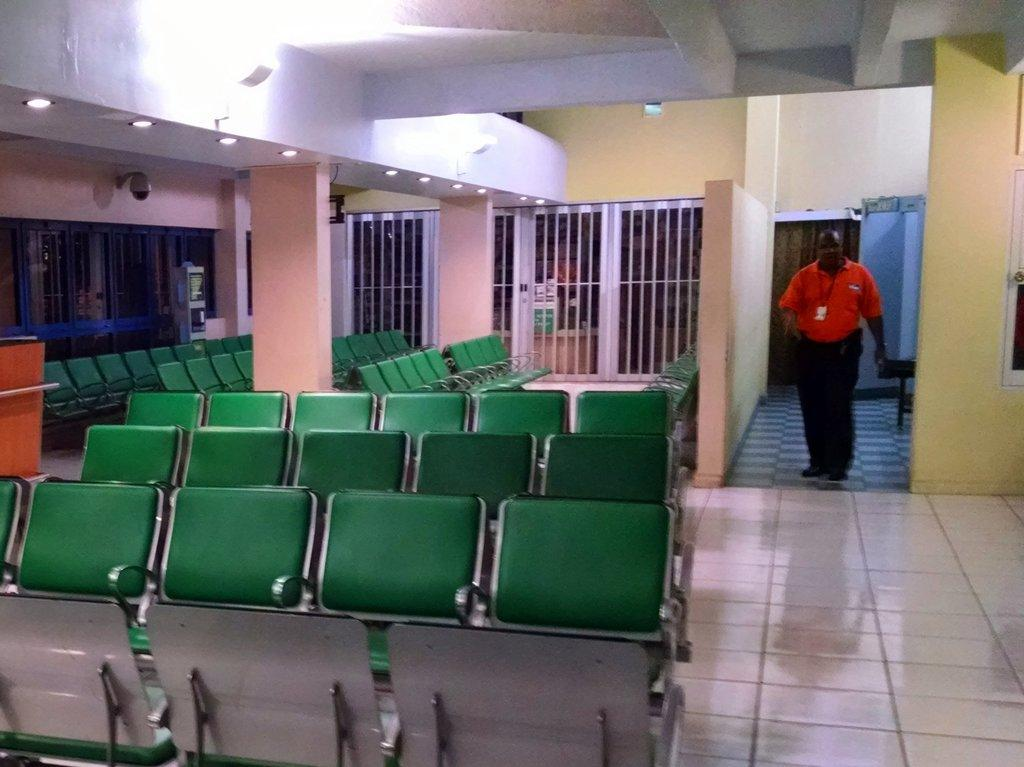Who is in the image? There is a man in the image. What type of surface is visible in the image? The image shows a floor. What type of furniture is present in the image? There are chairs in the image. What architectural features can be seen in the image? Pillars are present in the image. What can be used for illumination in the image? Lights are visible in the image. What is in the background of the image? There is a wall in the background of the image. What type of bait is being used to catch fish in the image? There is no fishing or bait present in the image; it features a man, floor, chairs, pillars, lights, and a wall. What type of lock is securing the door in the image? There is no door or lock present in the image. 